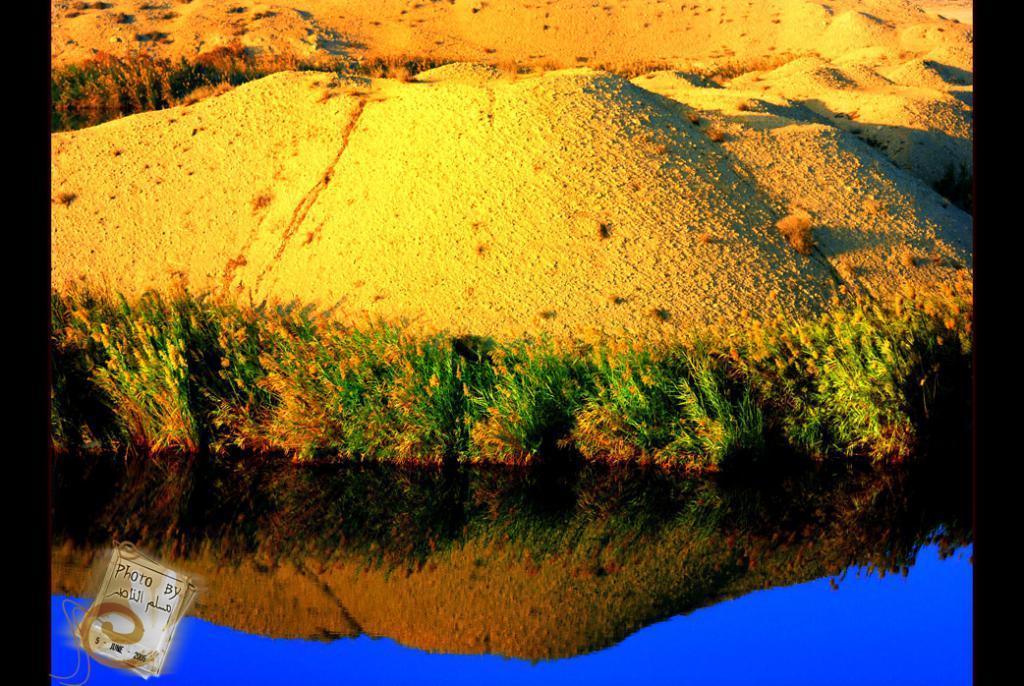What is visible in the image? There is water and plants visible in the image. Can you describe the water in the image? The water is visible, but its specific characteristics are not mentioned in the facts. What type of plants can be seen in the image? The facts do not specify the type of plants in the image. What industry is depicted in the image? There is no industry present in the image; it features water and plants. What time of day is it in the image? The time of day is not mentioned in the facts, so it cannot be determined from the image. 